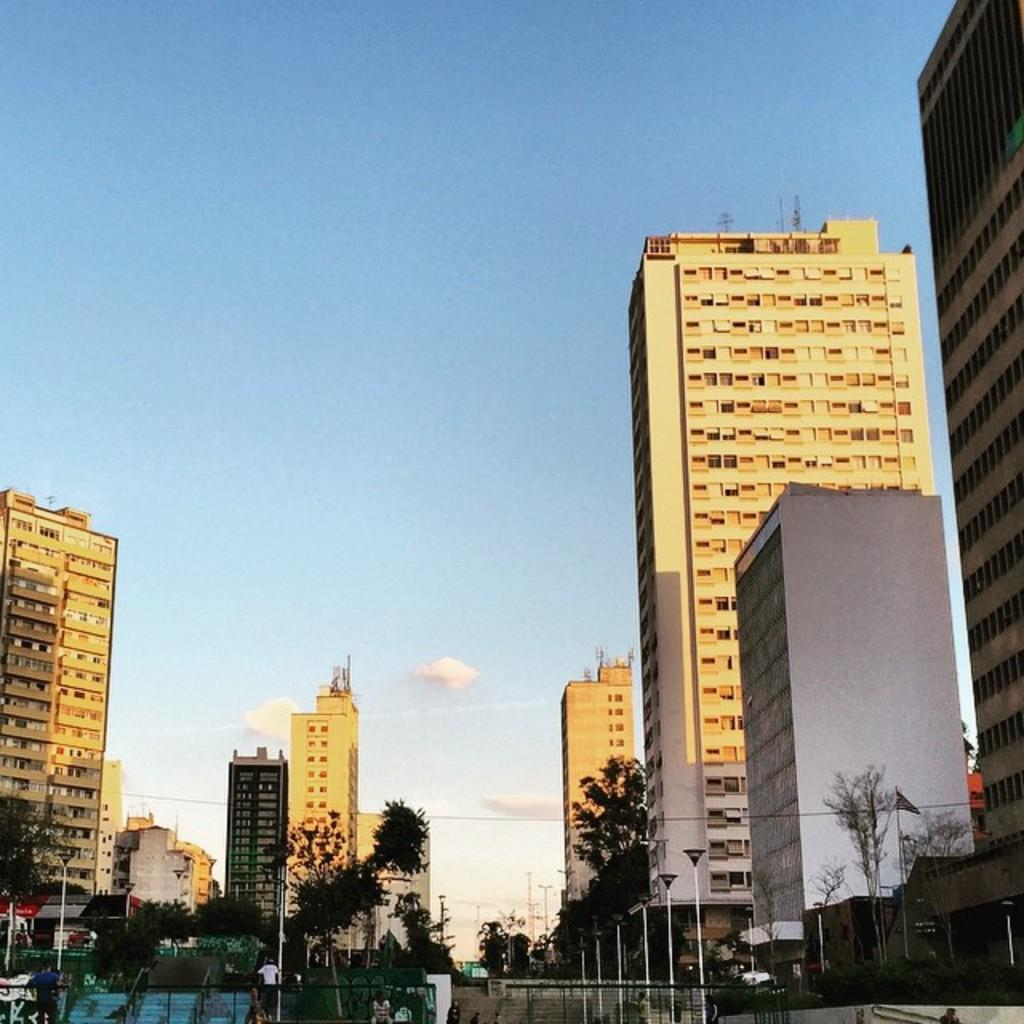What type of structures can be seen in the image? There are buildings and skyscrapers in the image. What is located in front of the buildings? Trees and street light poles are visible in front of the buildings. What is visible element is at the top of the image? The sky is visible at the top of the image. What type of stone is being used to build the cart in the image? There is no cart present in the image, so it is not possible to determine the type of stone being used. 